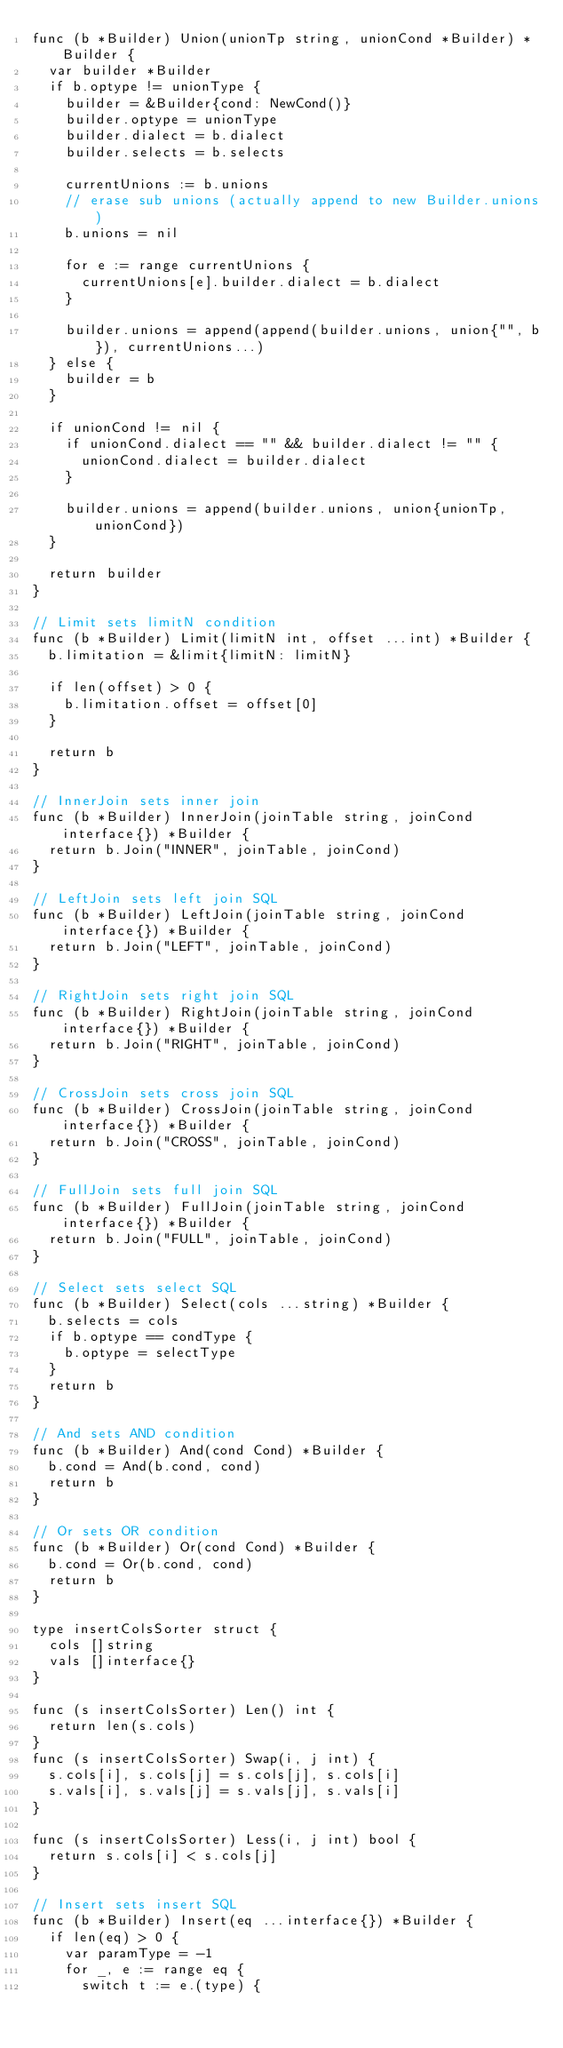<code> <loc_0><loc_0><loc_500><loc_500><_Go_>func (b *Builder) Union(unionTp string, unionCond *Builder) *Builder {
	var builder *Builder
	if b.optype != unionType {
		builder = &Builder{cond: NewCond()}
		builder.optype = unionType
		builder.dialect = b.dialect
		builder.selects = b.selects

		currentUnions := b.unions
		// erase sub unions (actually append to new Builder.unions)
		b.unions = nil

		for e := range currentUnions {
			currentUnions[e].builder.dialect = b.dialect
		}

		builder.unions = append(append(builder.unions, union{"", b}), currentUnions...)
	} else {
		builder = b
	}

	if unionCond != nil {
		if unionCond.dialect == "" && builder.dialect != "" {
			unionCond.dialect = builder.dialect
		}

		builder.unions = append(builder.unions, union{unionTp, unionCond})
	}

	return builder
}

// Limit sets limitN condition
func (b *Builder) Limit(limitN int, offset ...int) *Builder {
	b.limitation = &limit{limitN: limitN}

	if len(offset) > 0 {
		b.limitation.offset = offset[0]
	}

	return b
}

// InnerJoin sets inner join
func (b *Builder) InnerJoin(joinTable string, joinCond interface{}) *Builder {
	return b.Join("INNER", joinTable, joinCond)
}

// LeftJoin sets left join SQL
func (b *Builder) LeftJoin(joinTable string, joinCond interface{}) *Builder {
	return b.Join("LEFT", joinTable, joinCond)
}

// RightJoin sets right join SQL
func (b *Builder) RightJoin(joinTable string, joinCond interface{}) *Builder {
	return b.Join("RIGHT", joinTable, joinCond)
}

// CrossJoin sets cross join SQL
func (b *Builder) CrossJoin(joinTable string, joinCond interface{}) *Builder {
	return b.Join("CROSS", joinTable, joinCond)
}

// FullJoin sets full join SQL
func (b *Builder) FullJoin(joinTable string, joinCond interface{}) *Builder {
	return b.Join("FULL", joinTable, joinCond)
}

// Select sets select SQL
func (b *Builder) Select(cols ...string) *Builder {
	b.selects = cols
	if b.optype == condType {
		b.optype = selectType
	}
	return b
}

// And sets AND condition
func (b *Builder) And(cond Cond) *Builder {
	b.cond = And(b.cond, cond)
	return b
}

// Or sets OR condition
func (b *Builder) Or(cond Cond) *Builder {
	b.cond = Or(b.cond, cond)
	return b
}

type insertColsSorter struct {
	cols []string
	vals []interface{}
}

func (s insertColsSorter) Len() int {
	return len(s.cols)
}
func (s insertColsSorter) Swap(i, j int) {
	s.cols[i], s.cols[j] = s.cols[j], s.cols[i]
	s.vals[i], s.vals[j] = s.vals[j], s.vals[i]
}

func (s insertColsSorter) Less(i, j int) bool {
	return s.cols[i] < s.cols[j]
}

// Insert sets insert SQL
func (b *Builder) Insert(eq ...interface{}) *Builder {
	if len(eq) > 0 {
		var paramType = -1
		for _, e := range eq {
			switch t := e.(type) {</code> 